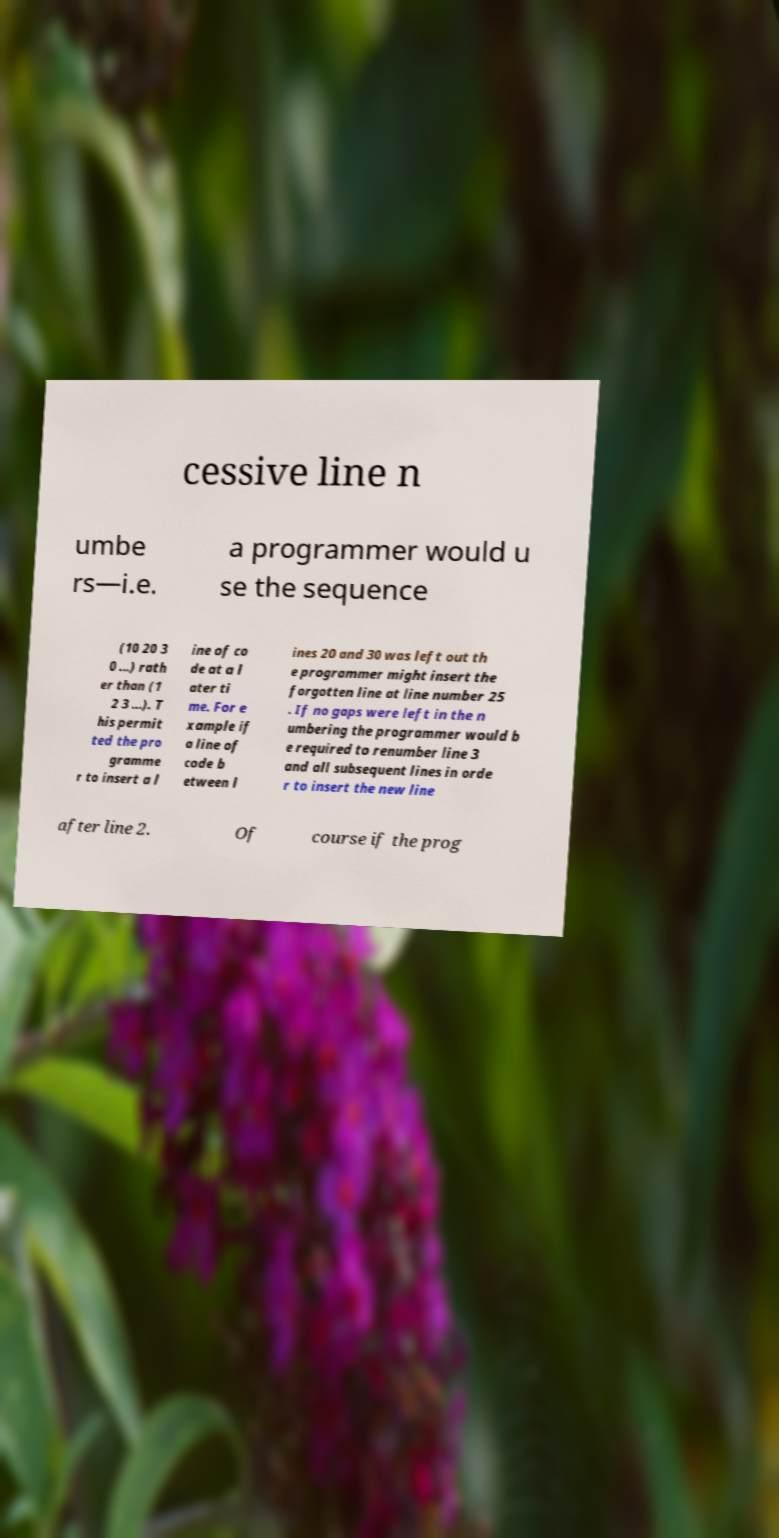For documentation purposes, I need the text within this image transcribed. Could you provide that? cessive line n umbe rs—i.e. a programmer would u se the sequence (10 20 3 0 ...) rath er than (1 2 3 ...). T his permit ted the pro gramme r to insert a l ine of co de at a l ater ti me. For e xample if a line of code b etween l ines 20 and 30 was left out th e programmer might insert the forgotten line at line number 25 . If no gaps were left in the n umbering the programmer would b e required to renumber line 3 and all subsequent lines in orde r to insert the new line after line 2. Of course if the prog 